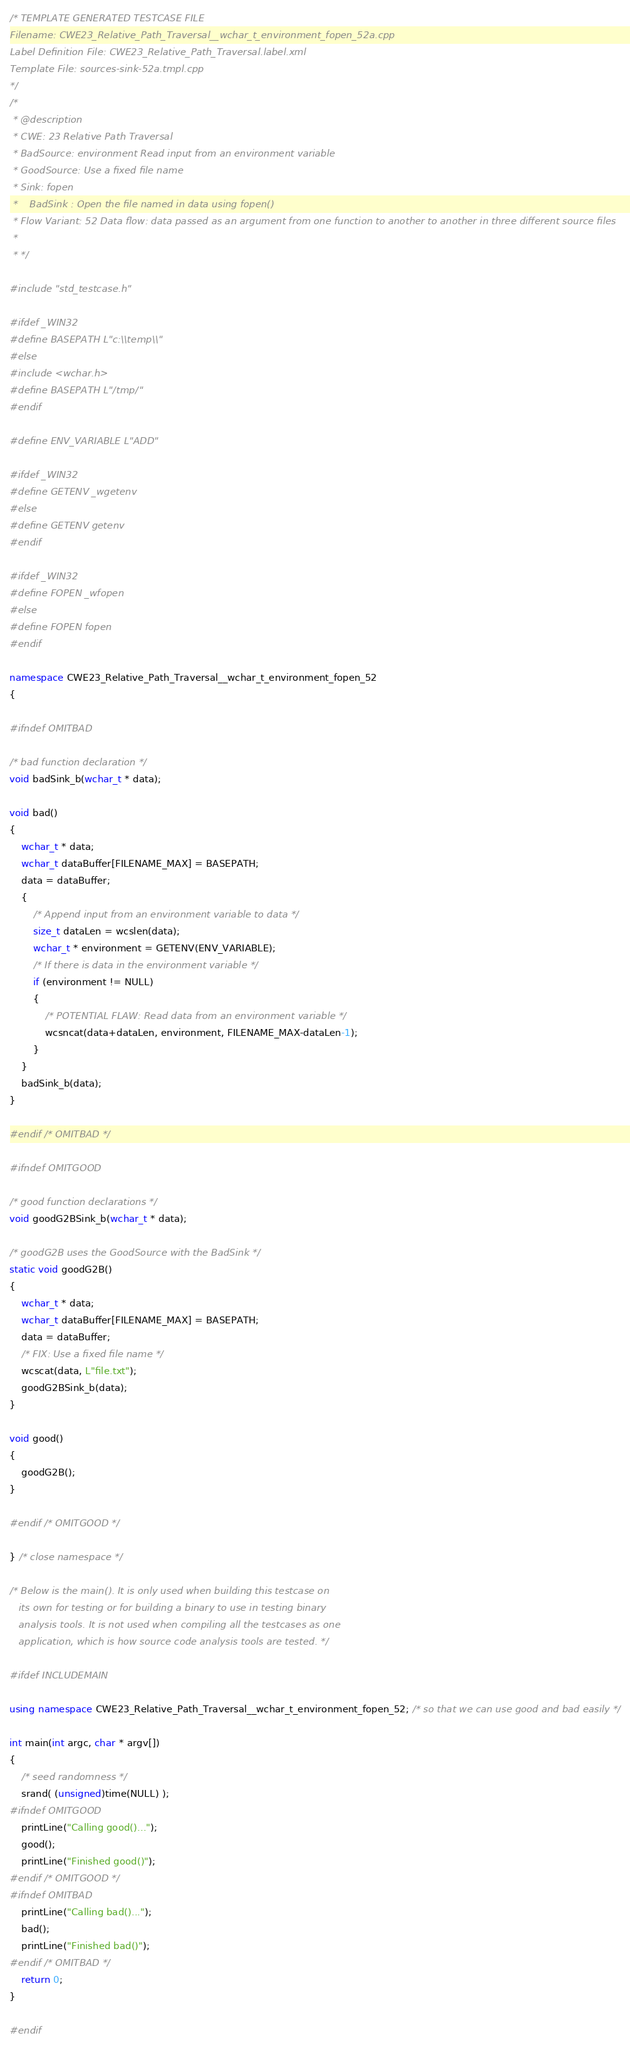Convert code to text. <code><loc_0><loc_0><loc_500><loc_500><_C++_>/* TEMPLATE GENERATED TESTCASE FILE
Filename: CWE23_Relative_Path_Traversal__wchar_t_environment_fopen_52a.cpp
Label Definition File: CWE23_Relative_Path_Traversal.label.xml
Template File: sources-sink-52a.tmpl.cpp
*/
/*
 * @description
 * CWE: 23 Relative Path Traversal
 * BadSource: environment Read input from an environment variable
 * GoodSource: Use a fixed file name
 * Sink: fopen
 *    BadSink : Open the file named in data using fopen()
 * Flow Variant: 52 Data flow: data passed as an argument from one function to another to another in three different source files
 *
 * */

#include "std_testcase.h"

#ifdef _WIN32
#define BASEPATH L"c:\\temp\\"
#else
#include <wchar.h>
#define BASEPATH L"/tmp/"
#endif

#define ENV_VARIABLE L"ADD"

#ifdef _WIN32
#define GETENV _wgetenv
#else
#define GETENV getenv
#endif

#ifdef _WIN32
#define FOPEN _wfopen
#else
#define FOPEN fopen
#endif

namespace CWE23_Relative_Path_Traversal__wchar_t_environment_fopen_52
{

#ifndef OMITBAD

/* bad function declaration */
void badSink_b(wchar_t * data);

void bad()
{
    wchar_t * data;
    wchar_t dataBuffer[FILENAME_MAX] = BASEPATH;
    data = dataBuffer;
    {
        /* Append input from an environment variable to data */
        size_t dataLen = wcslen(data);
        wchar_t * environment = GETENV(ENV_VARIABLE);
        /* If there is data in the environment variable */
        if (environment != NULL)
        {
            /* POTENTIAL FLAW: Read data from an environment variable */
            wcsncat(data+dataLen, environment, FILENAME_MAX-dataLen-1);
        }
    }
    badSink_b(data);
}

#endif /* OMITBAD */

#ifndef OMITGOOD

/* good function declarations */
void goodG2BSink_b(wchar_t * data);

/* goodG2B uses the GoodSource with the BadSink */
static void goodG2B()
{
    wchar_t * data;
    wchar_t dataBuffer[FILENAME_MAX] = BASEPATH;
    data = dataBuffer;
    /* FIX: Use a fixed file name */
    wcscat(data, L"file.txt");
    goodG2BSink_b(data);
}

void good()
{
    goodG2B();
}

#endif /* OMITGOOD */

} /* close namespace */

/* Below is the main(). It is only used when building this testcase on
   its own for testing or for building a binary to use in testing binary
   analysis tools. It is not used when compiling all the testcases as one
   application, which is how source code analysis tools are tested. */

#ifdef INCLUDEMAIN

using namespace CWE23_Relative_Path_Traversal__wchar_t_environment_fopen_52; /* so that we can use good and bad easily */

int main(int argc, char * argv[])
{
    /* seed randomness */
    srand( (unsigned)time(NULL) );
#ifndef OMITGOOD
    printLine("Calling good()...");
    good();
    printLine("Finished good()");
#endif /* OMITGOOD */
#ifndef OMITBAD
    printLine("Calling bad()...");
    bad();
    printLine("Finished bad()");
#endif /* OMITBAD */
    return 0;
}

#endif
</code> 